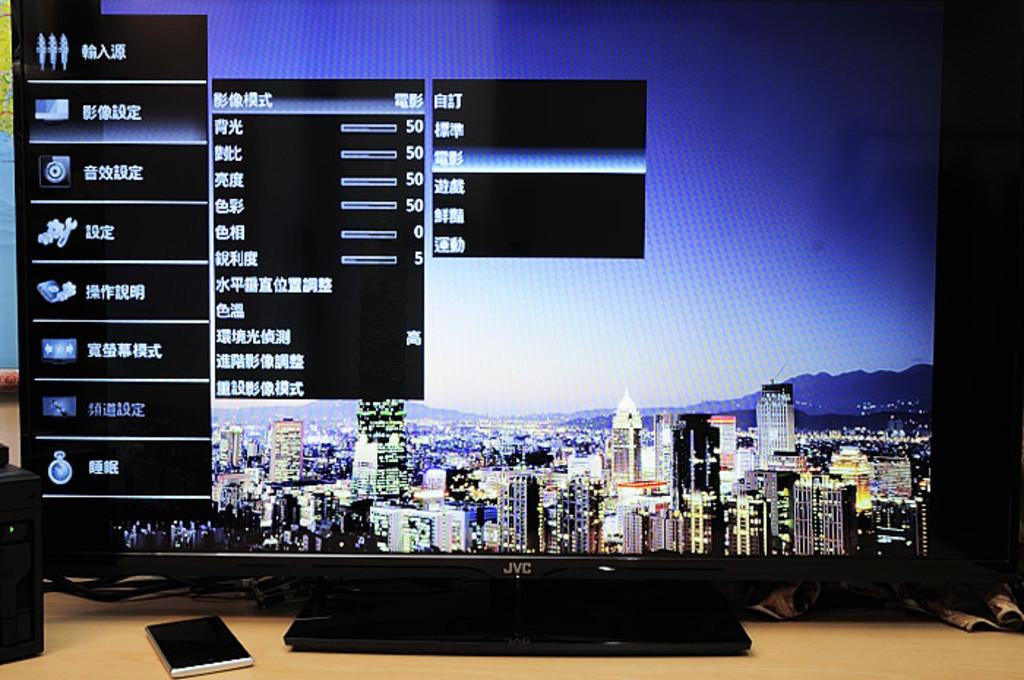<image>
Write a terse but informative summary of the picture. A black JVC computer monitor with a screen background of a city-scape and a settings prompt in Chinese displayed 